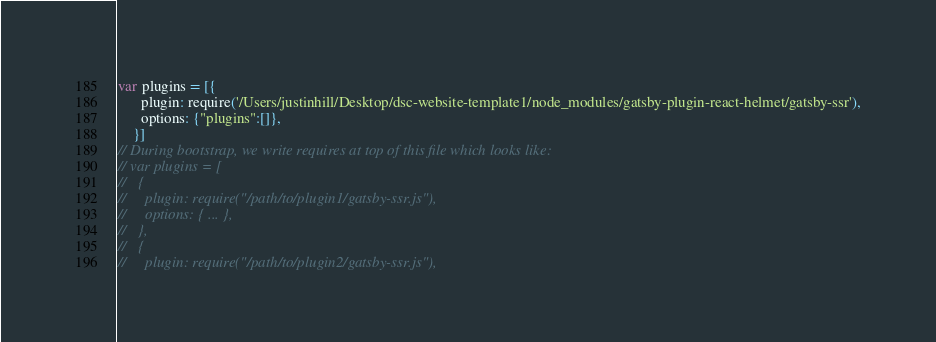Convert code to text. <code><loc_0><loc_0><loc_500><loc_500><_JavaScript_>var plugins = [{
      plugin: require('/Users/justinhill/Desktop/dsc-website-template1/node_modules/gatsby-plugin-react-helmet/gatsby-ssr'),
      options: {"plugins":[]},
    }]
// During bootstrap, we write requires at top of this file which looks like:
// var plugins = [
//   {
//     plugin: require("/path/to/plugin1/gatsby-ssr.js"),
//     options: { ... },
//   },
//   {
//     plugin: require("/path/to/plugin2/gatsby-ssr.js"),</code> 